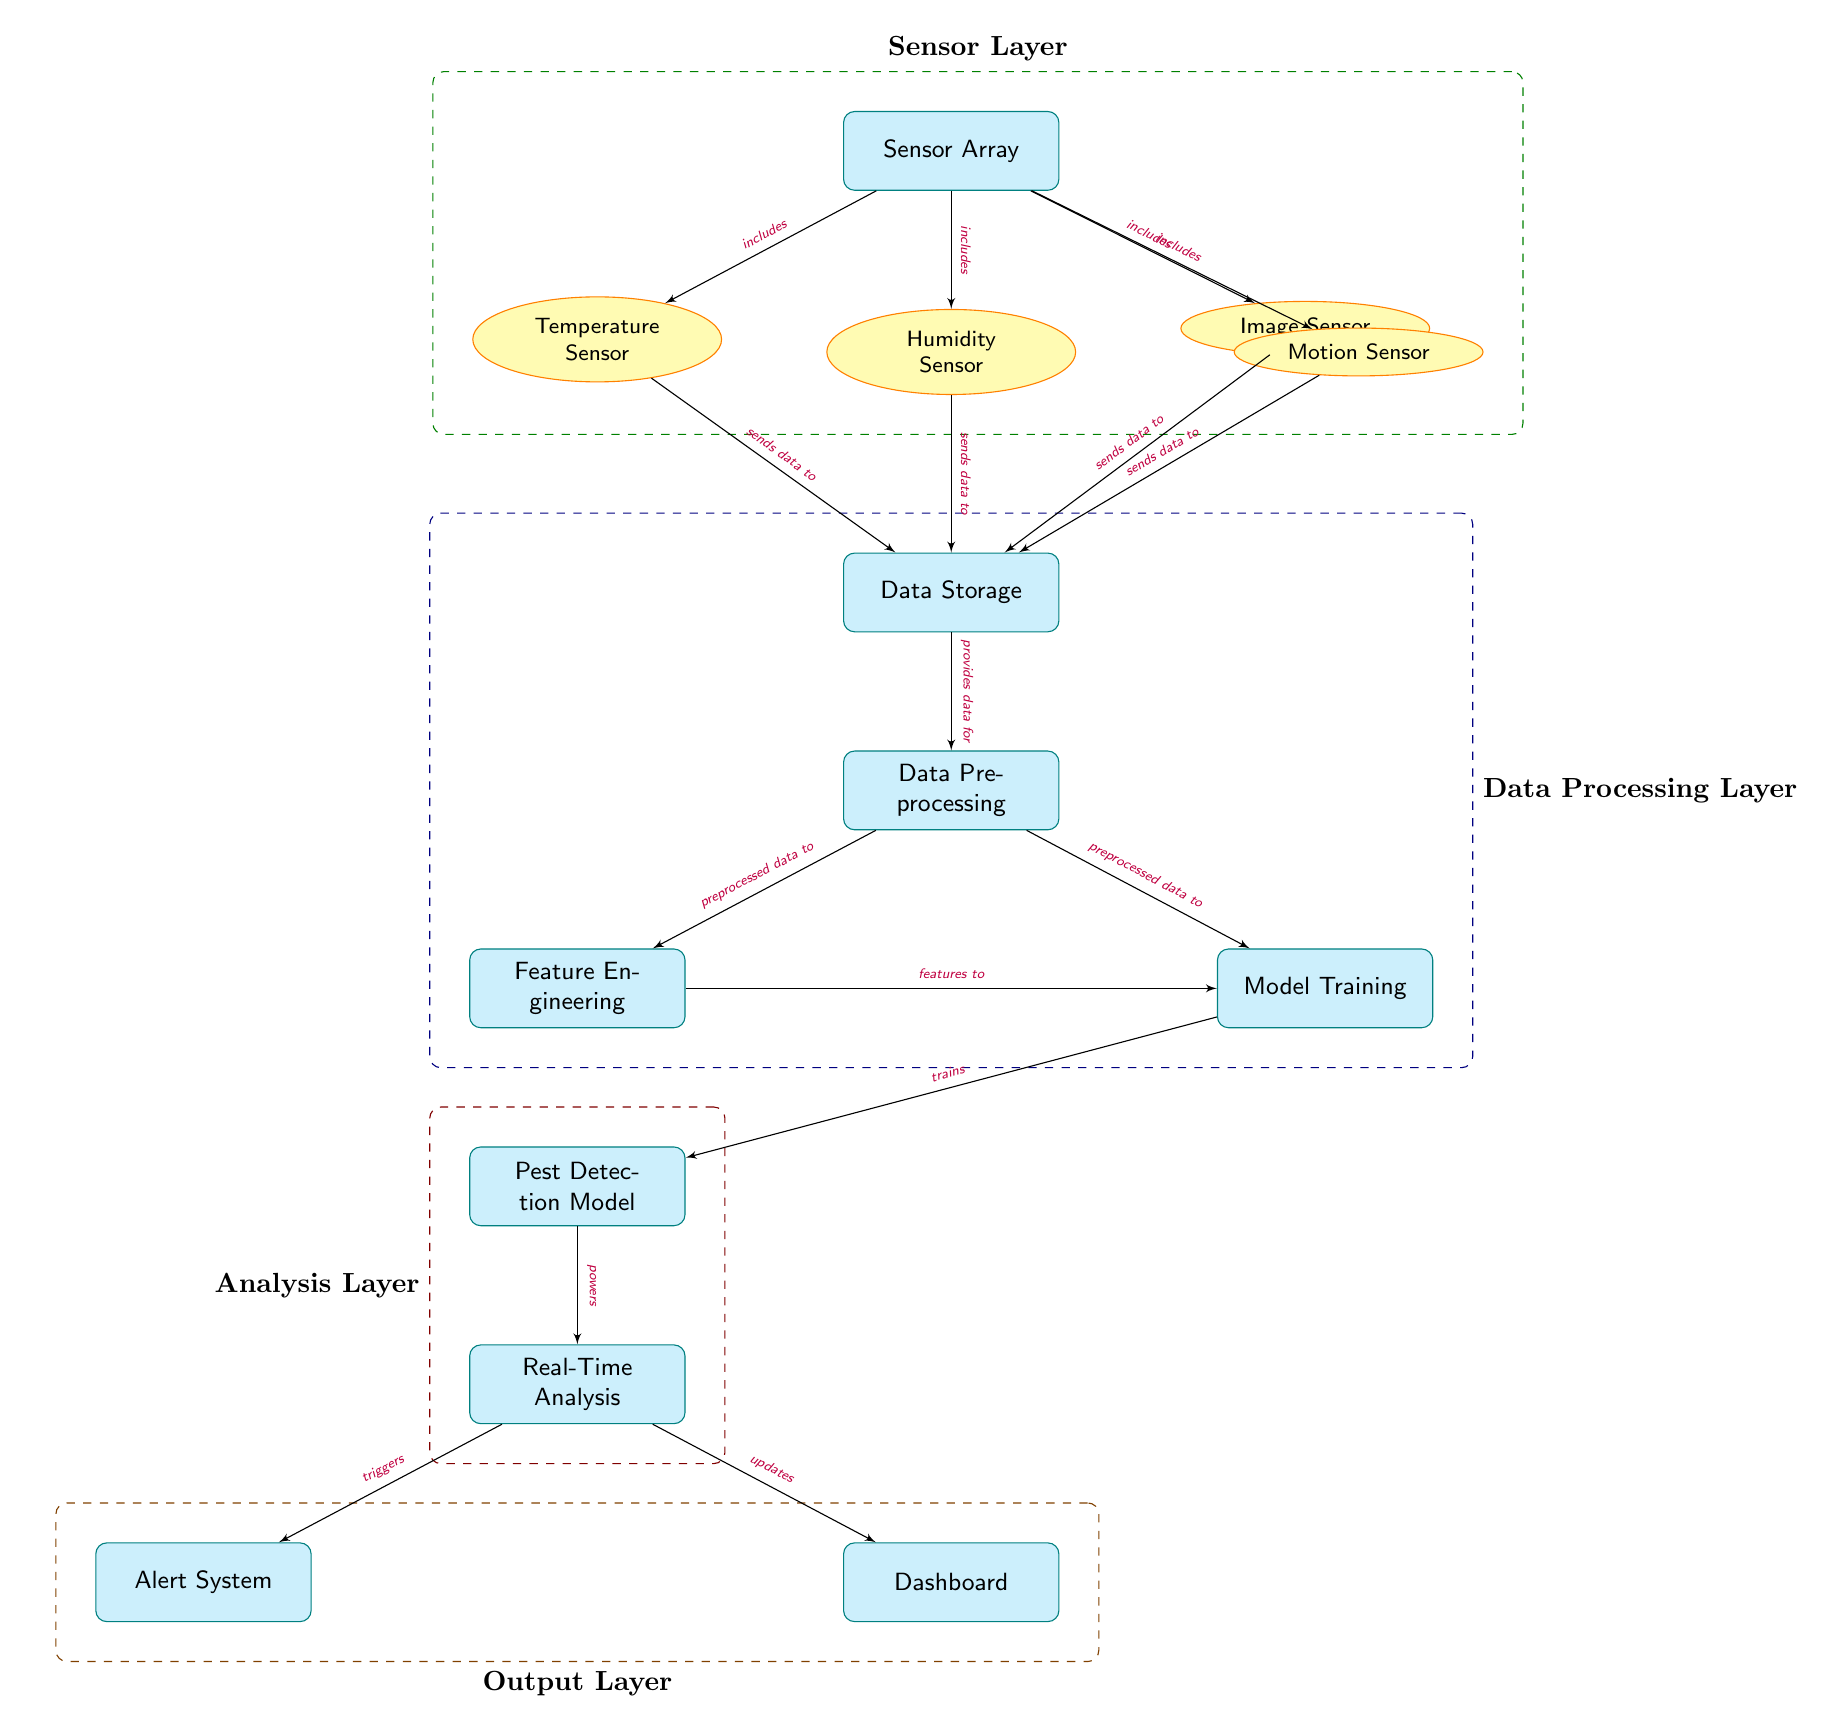What's the total number of sensors in the diagram? The diagram outlines four distinct sensors: Temperature Sensor, Humidity Sensor, Image Sensor, and Motion Sensor. By counting these, we can determine that the total number of sensors is four.
Answer: 4 What does the Sensor Array include? The Sensor Array includes the Temperature Sensor, Humidity Sensor, Image Sensor, and Motion Sensor, as indicated by the arrows pointing from the sensor array to each sensor.
Answer: Temperature Sensor, Humidity Sensor, Image Sensor, Motion Sensor What is the output generated by the Real-Time Analysis? The Real-Time Analysis triggers the Alert System and updates the Dashboard as indicated by the arrows that lead from this node to both output nodes.
Answer: Alert System, Dashboard Which layer is responsible for data preprocessing? The Data Processing Layer contains the Data Preprocessing node, which is positioned directly below Data Storage, indicating its function in the preprocessing of data.
Answer: Data Processing Layer How do the features get to the Model Training? The features are provided to the Model Training node from the Feature Engineering node, as depicted by the directed arrow connecting these two nodes in the diagram.
Answer: Feature Engineering What data do sensors send to Data Storage? Each sensor, including Temperature Sensor, Humidity Sensor, Image Sensor, and Motion Sensor, sends its respective data to Data Storage, as indicated by the arrows from each sensor pointing towards Data Storage.
Answer: Data from all sensors What role does the Pest Detection Model play in the system? The Pest Detection Model is trained by the Model Training node and directly powers the Real-Time Analysis node, as shown by the outgoing arrow indicating this relationship.
Answer: Powers Real-Time Analysis How is the feature engineering related to model training? Feature Engineering sends features to Model Training, which signifies a direct relationship where processed features are required to train the model, as shown by the arrow between these nodes.
Answer: Sends features to Model Training What types of alerts does the system potentially trigger? The diagram indicates that the Real-Time Analysis triggers the Alert System, which implies that various alerts about pest detection could be generated, although specific types are not directly listed in the visible data.
Answer: Alerts about pest detection 